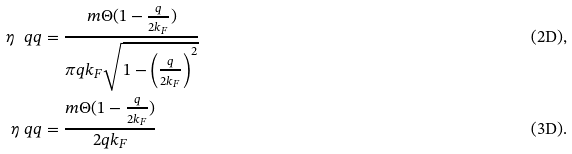Convert formula to latex. <formula><loc_0><loc_0><loc_500><loc_500>\eta _ { \ } q q & = \frac { m \Theta ( 1 - \frac { q } { 2 k _ { F } } ) } { \pi q k _ { F } \sqrt { 1 - \left ( \frac { q } { 2 k _ { F } } \right ) ^ { 2 } } } & \text {(2D)} , \\ \eta _ { \ } q q & = \frac { m \Theta ( 1 - \frac { q } { 2 k _ { F } } ) } { 2 q k _ { F } } & \text {(3D)} .</formula> 